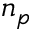<formula> <loc_0><loc_0><loc_500><loc_500>n _ { p }</formula> 